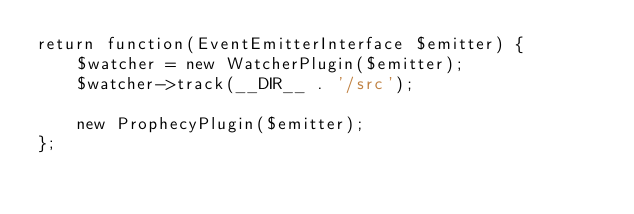<code> <loc_0><loc_0><loc_500><loc_500><_PHP_>return function(EventEmitterInterface $emitter) {
    $watcher = new WatcherPlugin($emitter);
    $watcher->track(__DIR__ . '/src');

    new ProphecyPlugin($emitter);
};</code> 